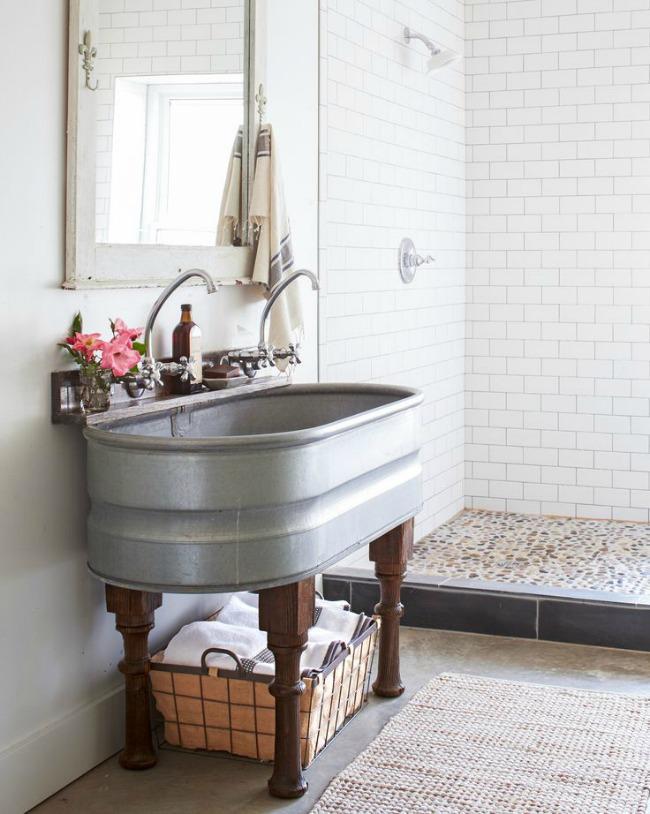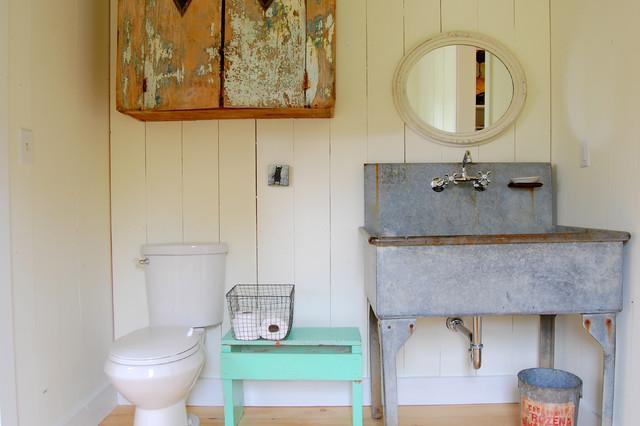The first image is the image on the left, the second image is the image on the right. Evaluate the accuracy of this statement regarding the images: "A row of three saucer shape lights are suspended above a mirror and sink.". Is it true? Answer yes or no. No. The first image is the image on the left, the second image is the image on the right. Given the left and right images, does the statement "At least two rolls of toilet paper are in a container and near a sink." hold true? Answer yes or no. Yes. 